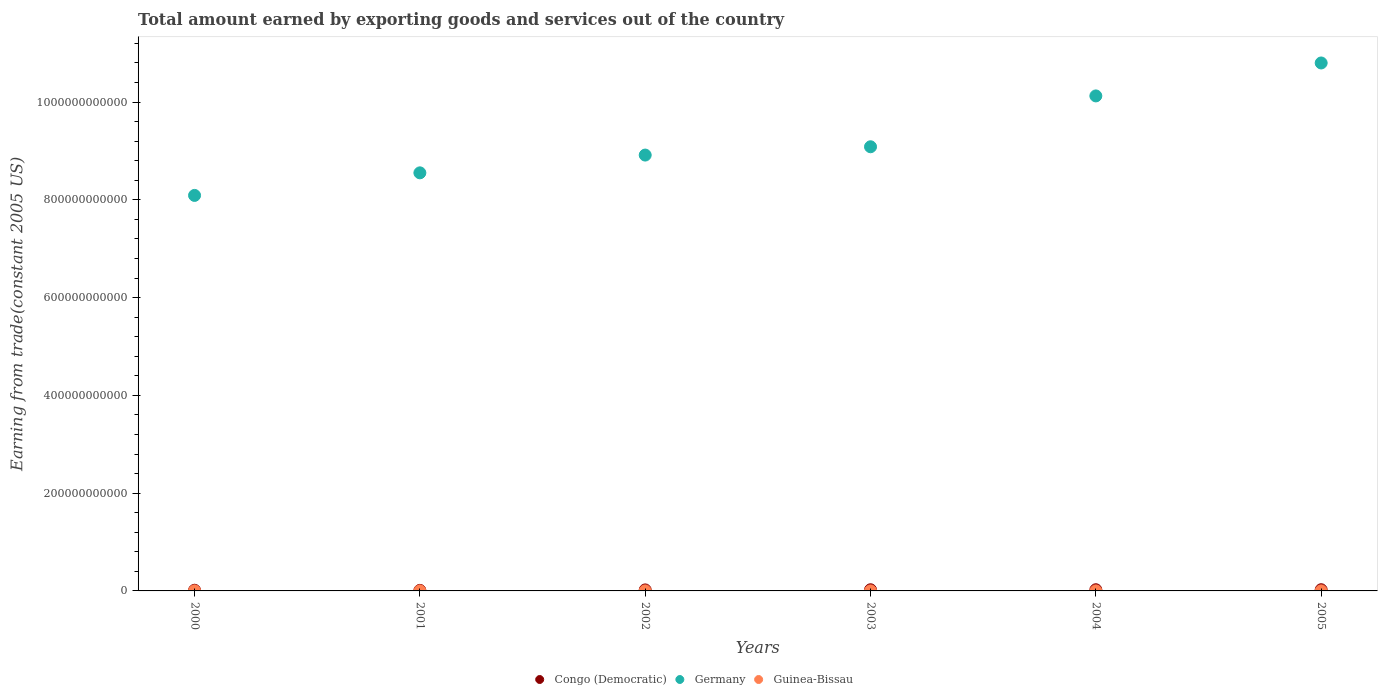What is the total amount earned by exporting goods and services in Guinea-Bissau in 2002?
Offer a terse response. 8.60e+07. Across all years, what is the maximum total amount earned by exporting goods and services in Congo (Democratic)?
Provide a short and direct response. 2.44e+09. Across all years, what is the minimum total amount earned by exporting goods and services in Guinea-Bissau?
Your answer should be compact. 7.27e+07. In which year was the total amount earned by exporting goods and services in Germany minimum?
Your answer should be compact. 2000. What is the total total amount earned by exporting goods and services in Germany in the graph?
Your answer should be compact. 5.56e+12. What is the difference between the total amount earned by exporting goods and services in Germany in 2003 and that in 2004?
Keep it short and to the point. -1.04e+11. What is the difference between the total amount earned by exporting goods and services in Congo (Democratic) in 2002 and the total amount earned by exporting goods and services in Germany in 2005?
Keep it short and to the point. -1.08e+12. What is the average total amount earned by exporting goods and services in Germany per year?
Keep it short and to the point. 9.26e+11. In the year 2002, what is the difference between the total amount earned by exporting goods and services in Congo (Democratic) and total amount earned by exporting goods and services in Guinea-Bissau?
Provide a succinct answer. 1.97e+09. In how many years, is the total amount earned by exporting goods and services in Congo (Democratic) greater than 560000000000 US$?
Provide a short and direct response. 0. What is the ratio of the total amount earned by exporting goods and services in Guinea-Bissau in 2001 to that in 2005?
Provide a short and direct response. 0.91. What is the difference between the highest and the second highest total amount earned by exporting goods and services in Germany?
Provide a short and direct response. 6.74e+1. What is the difference between the highest and the lowest total amount earned by exporting goods and services in Congo (Democratic)?
Make the answer very short. 1.31e+09. Is the sum of the total amount earned by exporting goods and services in Guinea-Bissau in 2000 and 2004 greater than the maximum total amount earned by exporting goods and services in Germany across all years?
Your answer should be very brief. No. Does the total amount earned by exporting goods and services in Guinea-Bissau monotonically increase over the years?
Your answer should be very brief. No. Is the total amount earned by exporting goods and services in Guinea-Bissau strictly less than the total amount earned by exporting goods and services in Congo (Democratic) over the years?
Your answer should be very brief. Yes. How many dotlines are there?
Your answer should be compact. 3. What is the difference between two consecutive major ticks on the Y-axis?
Ensure brevity in your answer.  2.00e+11. Where does the legend appear in the graph?
Provide a succinct answer. Bottom center. How many legend labels are there?
Make the answer very short. 3. What is the title of the graph?
Your response must be concise. Total amount earned by exporting goods and services out of the country. What is the label or title of the X-axis?
Provide a succinct answer. Years. What is the label or title of the Y-axis?
Offer a terse response. Earning from trade(constant 2005 US). What is the Earning from trade(constant 2005 US) of Congo (Democratic) in 2000?
Your answer should be compact. 1.40e+09. What is the Earning from trade(constant 2005 US) in Germany in 2000?
Your answer should be compact. 8.09e+11. What is the Earning from trade(constant 2005 US) in Guinea-Bissau in 2000?
Keep it short and to the point. 9.65e+07. What is the Earning from trade(constant 2005 US) of Congo (Democratic) in 2001?
Your answer should be very brief. 1.13e+09. What is the Earning from trade(constant 2005 US) of Germany in 2001?
Keep it short and to the point. 8.55e+11. What is the Earning from trade(constant 2005 US) in Guinea-Bissau in 2001?
Your answer should be very brief. 1.06e+08. What is the Earning from trade(constant 2005 US) of Congo (Democratic) in 2002?
Offer a terse response. 2.06e+09. What is the Earning from trade(constant 2005 US) of Germany in 2002?
Offer a very short reply. 8.92e+11. What is the Earning from trade(constant 2005 US) in Guinea-Bissau in 2002?
Provide a succinct answer. 8.60e+07. What is the Earning from trade(constant 2005 US) in Congo (Democratic) in 2003?
Provide a succinct answer. 2.36e+09. What is the Earning from trade(constant 2005 US) of Germany in 2003?
Provide a short and direct response. 9.09e+11. What is the Earning from trade(constant 2005 US) in Guinea-Bissau in 2003?
Provide a short and direct response. 7.27e+07. What is the Earning from trade(constant 2005 US) of Congo (Democratic) in 2004?
Provide a short and direct response. 2.43e+09. What is the Earning from trade(constant 2005 US) of Germany in 2004?
Give a very brief answer. 1.01e+12. What is the Earning from trade(constant 2005 US) in Guinea-Bissau in 2004?
Make the answer very short. 8.50e+07. What is the Earning from trade(constant 2005 US) in Congo (Democratic) in 2005?
Ensure brevity in your answer.  2.44e+09. What is the Earning from trade(constant 2005 US) in Germany in 2005?
Your answer should be very brief. 1.08e+12. What is the Earning from trade(constant 2005 US) of Guinea-Bissau in 2005?
Ensure brevity in your answer.  1.17e+08. Across all years, what is the maximum Earning from trade(constant 2005 US) in Congo (Democratic)?
Ensure brevity in your answer.  2.44e+09. Across all years, what is the maximum Earning from trade(constant 2005 US) of Germany?
Provide a short and direct response. 1.08e+12. Across all years, what is the maximum Earning from trade(constant 2005 US) in Guinea-Bissau?
Provide a short and direct response. 1.17e+08. Across all years, what is the minimum Earning from trade(constant 2005 US) of Congo (Democratic)?
Ensure brevity in your answer.  1.13e+09. Across all years, what is the minimum Earning from trade(constant 2005 US) in Germany?
Make the answer very short. 8.09e+11. Across all years, what is the minimum Earning from trade(constant 2005 US) of Guinea-Bissau?
Ensure brevity in your answer.  7.27e+07. What is the total Earning from trade(constant 2005 US) of Congo (Democratic) in the graph?
Offer a very short reply. 1.18e+1. What is the total Earning from trade(constant 2005 US) of Germany in the graph?
Keep it short and to the point. 5.56e+12. What is the total Earning from trade(constant 2005 US) of Guinea-Bissau in the graph?
Your answer should be compact. 5.63e+08. What is the difference between the Earning from trade(constant 2005 US) of Congo (Democratic) in 2000 and that in 2001?
Offer a terse response. 2.73e+08. What is the difference between the Earning from trade(constant 2005 US) of Germany in 2000 and that in 2001?
Provide a short and direct response. -4.62e+1. What is the difference between the Earning from trade(constant 2005 US) of Guinea-Bissau in 2000 and that in 2001?
Your answer should be compact. -9.87e+06. What is the difference between the Earning from trade(constant 2005 US) of Congo (Democratic) in 2000 and that in 2002?
Give a very brief answer. -6.58e+08. What is the difference between the Earning from trade(constant 2005 US) of Germany in 2000 and that in 2002?
Provide a short and direct response. -8.25e+1. What is the difference between the Earning from trade(constant 2005 US) of Guinea-Bissau in 2000 and that in 2002?
Ensure brevity in your answer.  1.06e+07. What is the difference between the Earning from trade(constant 2005 US) of Congo (Democratic) in 2000 and that in 2003?
Keep it short and to the point. -9.62e+08. What is the difference between the Earning from trade(constant 2005 US) of Germany in 2000 and that in 2003?
Provide a short and direct response. -9.95e+1. What is the difference between the Earning from trade(constant 2005 US) of Guinea-Bissau in 2000 and that in 2003?
Your answer should be compact. 2.39e+07. What is the difference between the Earning from trade(constant 2005 US) in Congo (Democratic) in 2000 and that in 2004?
Keep it short and to the point. -1.03e+09. What is the difference between the Earning from trade(constant 2005 US) in Germany in 2000 and that in 2004?
Give a very brief answer. -2.04e+11. What is the difference between the Earning from trade(constant 2005 US) of Guinea-Bissau in 2000 and that in 2004?
Give a very brief answer. 1.16e+07. What is the difference between the Earning from trade(constant 2005 US) in Congo (Democratic) in 2000 and that in 2005?
Offer a very short reply. -1.04e+09. What is the difference between the Earning from trade(constant 2005 US) of Germany in 2000 and that in 2005?
Your response must be concise. -2.71e+11. What is the difference between the Earning from trade(constant 2005 US) of Guinea-Bissau in 2000 and that in 2005?
Offer a terse response. -2.00e+07. What is the difference between the Earning from trade(constant 2005 US) of Congo (Democratic) in 2001 and that in 2002?
Your answer should be very brief. -9.31e+08. What is the difference between the Earning from trade(constant 2005 US) of Germany in 2001 and that in 2002?
Offer a very short reply. -3.64e+1. What is the difference between the Earning from trade(constant 2005 US) of Guinea-Bissau in 2001 and that in 2002?
Ensure brevity in your answer.  2.05e+07. What is the difference between the Earning from trade(constant 2005 US) of Congo (Democratic) in 2001 and that in 2003?
Offer a very short reply. -1.24e+09. What is the difference between the Earning from trade(constant 2005 US) of Germany in 2001 and that in 2003?
Ensure brevity in your answer.  -5.33e+1. What is the difference between the Earning from trade(constant 2005 US) of Guinea-Bissau in 2001 and that in 2003?
Offer a terse response. 3.38e+07. What is the difference between the Earning from trade(constant 2005 US) in Congo (Democratic) in 2001 and that in 2004?
Your response must be concise. -1.30e+09. What is the difference between the Earning from trade(constant 2005 US) of Germany in 2001 and that in 2004?
Your response must be concise. -1.57e+11. What is the difference between the Earning from trade(constant 2005 US) in Guinea-Bissau in 2001 and that in 2004?
Provide a succinct answer. 2.15e+07. What is the difference between the Earning from trade(constant 2005 US) of Congo (Democratic) in 2001 and that in 2005?
Your answer should be compact. -1.31e+09. What is the difference between the Earning from trade(constant 2005 US) in Germany in 2001 and that in 2005?
Provide a succinct answer. -2.25e+11. What is the difference between the Earning from trade(constant 2005 US) of Guinea-Bissau in 2001 and that in 2005?
Make the answer very short. -1.01e+07. What is the difference between the Earning from trade(constant 2005 US) in Congo (Democratic) in 2002 and that in 2003?
Offer a terse response. -3.04e+08. What is the difference between the Earning from trade(constant 2005 US) in Germany in 2002 and that in 2003?
Make the answer very short. -1.70e+1. What is the difference between the Earning from trade(constant 2005 US) of Guinea-Bissau in 2002 and that in 2003?
Ensure brevity in your answer.  1.33e+07. What is the difference between the Earning from trade(constant 2005 US) in Congo (Democratic) in 2002 and that in 2004?
Give a very brief answer. -3.69e+08. What is the difference between the Earning from trade(constant 2005 US) of Germany in 2002 and that in 2004?
Your answer should be compact. -1.21e+11. What is the difference between the Earning from trade(constant 2005 US) in Guinea-Bissau in 2002 and that in 2004?
Ensure brevity in your answer.  1.01e+06. What is the difference between the Earning from trade(constant 2005 US) of Congo (Democratic) in 2002 and that in 2005?
Keep it short and to the point. -3.82e+08. What is the difference between the Earning from trade(constant 2005 US) in Germany in 2002 and that in 2005?
Keep it short and to the point. -1.88e+11. What is the difference between the Earning from trade(constant 2005 US) in Guinea-Bissau in 2002 and that in 2005?
Keep it short and to the point. -3.05e+07. What is the difference between the Earning from trade(constant 2005 US) in Congo (Democratic) in 2003 and that in 2004?
Offer a terse response. -6.48e+07. What is the difference between the Earning from trade(constant 2005 US) of Germany in 2003 and that in 2004?
Your answer should be compact. -1.04e+11. What is the difference between the Earning from trade(constant 2005 US) of Guinea-Bissau in 2003 and that in 2004?
Provide a short and direct response. -1.23e+07. What is the difference between the Earning from trade(constant 2005 US) of Congo (Democratic) in 2003 and that in 2005?
Ensure brevity in your answer.  -7.79e+07. What is the difference between the Earning from trade(constant 2005 US) in Germany in 2003 and that in 2005?
Offer a very short reply. -1.71e+11. What is the difference between the Earning from trade(constant 2005 US) of Guinea-Bissau in 2003 and that in 2005?
Offer a very short reply. -4.38e+07. What is the difference between the Earning from trade(constant 2005 US) of Congo (Democratic) in 2004 and that in 2005?
Offer a very short reply. -1.31e+07. What is the difference between the Earning from trade(constant 2005 US) of Germany in 2004 and that in 2005?
Your answer should be very brief. -6.74e+1. What is the difference between the Earning from trade(constant 2005 US) in Guinea-Bissau in 2004 and that in 2005?
Your answer should be compact. -3.15e+07. What is the difference between the Earning from trade(constant 2005 US) of Congo (Democratic) in 2000 and the Earning from trade(constant 2005 US) of Germany in 2001?
Make the answer very short. -8.54e+11. What is the difference between the Earning from trade(constant 2005 US) in Congo (Democratic) in 2000 and the Earning from trade(constant 2005 US) in Guinea-Bissau in 2001?
Provide a succinct answer. 1.30e+09. What is the difference between the Earning from trade(constant 2005 US) in Germany in 2000 and the Earning from trade(constant 2005 US) in Guinea-Bissau in 2001?
Your answer should be compact. 8.09e+11. What is the difference between the Earning from trade(constant 2005 US) of Congo (Democratic) in 2000 and the Earning from trade(constant 2005 US) of Germany in 2002?
Your answer should be very brief. -8.90e+11. What is the difference between the Earning from trade(constant 2005 US) in Congo (Democratic) in 2000 and the Earning from trade(constant 2005 US) in Guinea-Bissau in 2002?
Ensure brevity in your answer.  1.32e+09. What is the difference between the Earning from trade(constant 2005 US) in Germany in 2000 and the Earning from trade(constant 2005 US) in Guinea-Bissau in 2002?
Your answer should be compact. 8.09e+11. What is the difference between the Earning from trade(constant 2005 US) in Congo (Democratic) in 2000 and the Earning from trade(constant 2005 US) in Germany in 2003?
Provide a short and direct response. -9.07e+11. What is the difference between the Earning from trade(constant 2005 US) in Congo (Democratic) in 2000 and the Earning from trade(constant 2005 US) in Guinea-Bissau in 2003?
Your response must be concise. 1.33e+09. What is the difference between the Earning from trade(constant 2005 US) in Germany in 2000 and the Earning from trade(constant 2005 US) in Guinea-Bissau in 2003?
Your response must be concise. 8.09e+11. What is the difference between the Earning from trade(constant 2005 US) of Congo (Democratic) in 2000 and the Earning from trade(constant 2005 US) of Germany in 2004?
Your answer should be very brief. -1.01e+12. What is the difference between the Earning from trade(constant 2005 US) of Congo (Democratic) in 2000 and the Earning from trade(constant 2005 US) of Guinea-Bissau in 2004?
Make the answer very short. 1.32e+09. What is the difference between the Earning from trade(constant 2005 US) in Germany in 2000 and the Earning from trade(constant 2005 US) in Guinea-Bissau in 2004?
Offer a terse response. 8.09e+11. What is the difference between the Earning from trade(constant 2005 US) of Congo (Democratic) in 2000 and the Earning from trade(constant 2005 US) of Germany in 2005?
Make the answer very short. -1.08e+12. What is the difference between the Earning from trade(constant 2005 US) of Congo (Democratic) in 2000 and the Earning from trade(constant 2005 US) of Guinea-Bissau in 2005?
Give a very brief answer. 1.29e+09. What is the difference between the Earning from trade(constant 2005 US) of Germany in 2000 and the Earning from trade(constant 2005 US) of Guinea-Bissau in 2005?
Give a very brief answer. 8.09e+11. What is the difference between the Earning from trade(constant 2005 US) of Congo (Democratic) in 2001 and the Earning from trade(constant 2005 US) of Germany in 2002?
Offer a terse response. -8.90e+11. What is the difference between the Earning from trade(constant 2005 US) in Congo (Democratic) in 2001 and the Earning from trade(constant 2005 US) in Guinea-Bissau in 2002?
Your response must be concise. 1.04e+09. What is the difference between the Earning from trade(constant 2005 US) of Germany in 2001 and the Earning from trade(constant 2005 US) of Guinea-Bissau in 2002?
Ensure brevity in your answer.  8.55e+11. What is the difference between the Earning from trade(constant 2005 US) of Congo (Democratic) in 2001 and the Earning from trade(constant 2005 US) of Germany in 2003?
Make the answer very short. -9.07e+11. What is the difference between the Earning from trade(constant 2005 US) in Congo (Democratic) in 2001 and the Earning from trade(constant 2005 US) in Guinea-Bissau in 2003?
Ensure brevity in your answer.  1.06e+09. What is the difference between the Earning from trade(constant 2005 US) in Germany in 2001 and the Earning from trade(constant 2005 US) in Guinea-Bissau in 2003?
Make the answer very short. 8.55e+11. What is the difference between the Earning from trade(constant 2005 US) in Congo (Democratic) in 2001 and the Earning from trade(constant 2005 US) in Germany in 2004?
Your answer should be compact. -1.01e+12. What is the difference between the Earning from trade(constant 2005 US) of Congo (Democratic) in 2001 and the Earning from trade(constant 2005 US) of Guinea-Bissau in 2004?
Your answer should be very brief. 1.04e+09. What is the difference between the Earning from trade(constant 2005 US) in Germany in 2001 and the Earning from trade(constant 2005 US) in Guinea-Bissau in 2004?
Your response must be concise. 8.55e+11. What is the difference between the Earning from trade(constant 2005 US) of Congo (Democratic) in 2001 and the Earning from trade(constant 2005 US) of Germany in 2005?
Offer a very short reply. -1.08e+12. What is the difference between the Earning from trade(constant 2005 US) of Congo (Democratic) in 2001 and the Earning from trade(constant 2005 US) of Guinea-Bissau in 2005?
Offer a terse response. 1.01e+09. What is the difference between the Earning from trade(constant 2005 US) in Germany in 2001 and the Earning from trade(constant 2005 US) in Guinea-Bissau in 2005?
Your answer should be very brief. 8.55e+11. What is the difference between the Earning from trade(constant 2005 US) in Congo (Democratic) in 2002 and the Earning from trade(constant 2005 US) in Germany in 2003?
Make the answer very short. -9.06e+11. What is the difference between the Earning from trade(constant 2005 US) in Congo (Democratic) in 2002 and the Earning from trade(constant 2005 US) in Guinea-Bissau in 2003?
Provide a succinct answer. 1.99e+09. What is the difference between the Earning from trade(constant 2005 US) in Germany in 2002 and the Earning from trade(constant 2005 US) in Guinea-Bissau in 2003?
Your response must be concise. 8.91e+11. What is the difference between the Earning from trade(constant 2005 US) of Congo (Democratic) in 2002 and the Earning from trade(constant 2005 US) of Germany in 2004?
Make the answer very short. -1.01e+12. What is the difference between the Earning from trade(constant 2005 US) of Congo (Democratic) in 2002 and the Earning from trade(constant 2005 US) of Guinea-Bissau in 2004?
Your answer should be compact. 1.98e+09. What is the difference between the Earning from trade(constant 2005 US) in Germany in 2002 and the Earning from trade(constant 2005 US) in Guinea-Bissau in 2004?
Ensure brevity in your answer.  8.91e+11. What is the difference between the Earning from trade(constant 2005 US) in Congo (Democratic) in 2002 and the Earning from trade(constant 2005 US) in Germany in 2005?
Your answer should be compact. -1.08e+12. What is the difference between the Earning from trade(constant 2005 US) of Congo (Democratic) in 2002 and the Earning from trade(constant 2005 US) of Guinea-Bissau in 2005?
Offer a very short reply. 1.94e+09. What is the difference between the Earning from trade(constant 2005 US) in Germany in 2002 and the Earning from trade(constant 2005 US) in Guinea-Bissau in 2005?
Keep it short and to the point. 8.91e+11. What is the difference between the Earning from trade(constant 2005 US) in Congo (Democratic) in 2003 and the Earning from trade(constant 2005 US) in Germany in 2004?
Your answer should be very brief. -1.01e+12. What is the difference between the Earning from trade(constant 2005 US) in Congo (Democratic) in 2003 and the Earning from trade(constant 2005 US) in Guinea-Bissau in 2004?
Provide a succinct answer. 2.28e+09. What is the difference between the Earning from trade(constant 2005 US) in Germany in 2003 and the Earning from trade(constant 2005 US) in Guinea-Bissau in 2004?
Offer a terse response. 9.08e+11. What is the difference between the Earning from trade(constant 2005 US) in Congo (Democratic) in 2003 and the Earning from trade(constant 2005 US) in Germany in 2005?
Keep it short and to the point. -1.08e+12. What is the difference between the Earning from trade(constant 2005 US) of Congo (Democratic) in 2003 and the Earning from trade(constant 2005 US) of Guinea-Bissau in 2005?
Ensure brevity in your answer.  2.25e+09. What is the difference between the Earning from trade(constant 2005 US) in Germany in 2003 and the Earning from trade(constant 2005 US) in Guinea-Bissau in 2005?
Your answer should be very brief. 9.08e+11. What is the difference between the Earning from trade(constant 2005 US) of Congo (Democratic) in 2004 and the Earning from trade(constant 2005 US) of Germany in 2005?
Offer a very short reply. -1.08e+12. What is the difference between the Earning from trade(constant 2005 US) of Congo (Democratic) in 2004 and the Earning from trade(constant 2005 US) of Guinea-Bissau in 2005?
Your response must be concise. 2.31e+09. What is the difference between the Earning from trade(constant 2005 US) of Germany in 2004 and the Earning from trade(constant 2005 US) of Guinea-Bissau in 2005?
Provide a succinct answer. 1.01e+12. What is the average Earning from trade(constant 2005 US) of Congo (Democratic) per year?
Provide a succinct answer. 1.97e+09. What is the average Earning from trade(constant 2005 US) in Germany per year?
Your response must be concise. 9.26e+11. What is the average Earning from trade(constant 2005 US) in Guinea-Bissau per year?
Ensure brevity in your answer.  9.38e+07. In the year 2000, what is the difference between the Earning from trade(constant 2005 US) in Congo (Democratic) and Earning from trade(constant 2005 US) in Germany?
Offer a terse response. -8.08e+11. In the year 2000, what is the difference between the Earning from trade(constant 2005 US) in Congo (Democratic) and Earning from trade(constant 2005 US) in Guinea-Bissau?
Offer a terse response. 1.31e+09. In the year 2000, what is the difference between the Earning from trade(constant 2005 US) in Germany and Earning from trade(constant 2005 US) in Guinea-Bissau?
Offer a terse response. 8.09e+11. In the year 2001, what is the difference between the Earning from trade(constant 2005 US) in Congo (Democratic) and Earning from trade(constant 2005 US) in Germany?
Your answer should be compact. -8.54e+11. In the year 2001, what is the difference between the Earning from trade(constant 2005 US) of Congo (Democratic) and Earning from trade(constant 2005 US) of Guinea-Bissau?
Your answer should be very brief. 1.02e+09. In the year 2001, what is the difference between the Earning from trade(constant 2005 US) of Germany and Earning from trade(constant 2005 US) of Guinea-Bissau?
Your answer should be very brief. 8.55e+11. In the year 2002, what is the difference between the Earning from trade(constant 2005 US) in Congo (Democratic) and Earning from trade(constant 2005 US) in Germany?
Ensure brevity in your answer.  -8.89e+11. In the year 2002, what is the difference between the Earning from trade(constant 2005 US) of Congo (Democratic) and Earning from trade(constant 2005 US) of Guinea-Bissau?
Make the answer very short. 1.97e+09. In the year 2002, what is the difference between the Earning from trade(constant 2005 US) in Germany and Earning from trade(constant 2005 US) in Guinea-Bissau?
Provide a short and direct response. 8.91e+11. In the year 2003, what is the difference between the Earning from trade(constant 2005 US) in Congo (Democratic) and Earning from trade(constant 2005 US) in Germany?
Offer a terse response. -9.06e+11. In the year 2003, what is the difference between the Earning from trade(constant 2005 US) in Congo (Democratic) and Earning from trade(constant 2005 US) in Guinea-Bissau?
Offer a very short reply. 2.29e+09. In the year 2003, what is the difference between the Earning from trade(constant 2005 US) in Germany and Earning from trade(constant 2005 US) in Guinea-Bissau?
Ensure brevity in your answer.  9.08e+11. In the year 2004, what is the difference between the Earning from trade(constant 2005 US) of Congo (Democratic) and Earning from trade(constant 2005 US) of Germany?
Ensure brevity in your answer.  -1.01e+12. In the year 2004, what is the difference between the Earning from trade(constant 2005 US) in Congo (Democratic) and Earning from trade(constant 2005 US) in Guinea-Bissau?
Keep it short and to the point. 2.34e+09. In the year 2004, what is the difference between the Earning from trade(constant 2005 US) in Germany and Earning from trade(constant 2005 US) in Guinea-Bissau?
Offer a very short reply. 1.01e+12. In the year 2005, what is the difference between the Earning from trade(constant 2005 US) of Congo (Democratic) and Earning from trade(constant 2005 US) of Germany?
Make the answer very short. -1.08e+12. In the year 2005, what is the difference between the Earning from trade(constant 2005 US) of Congo (Democratic) and Earning from trade(constant 2005 US) of Guinea-Bissau?
Provide a short and direct response. 2.33e+09. In the year 2005, what is the difference between the Earning from trade(constant 2005 US) of Germany and Earning from trade(constant 2005 US) of Guinea-Bissau?
Give a very brief answer. 1.08e+12. What is the ratio of the Earning from trade(constant 2005 US) of Congo (Democratic) in 2000 to that in 2001?
Offer a terse response. 1.24. What is the ratio of the Earning from trade(constant 2005 US) of Germany in 2000 to that in 2001?
Your answer should be very brief. 0.95. What is the ratio of the Earning from trade(constant 2005 US) in Guinea-Bissau in 2000 to that in 2001?
Offer a terse response. 0.91. What is the ratio of the Earning from trade(constant 2005 US) in Congo (Democratic) in 2000 to that in 2002?
Your answer should be compact. 0.68. What is the ratio of the Earning from trade(constant 2005 US) of Germany in 2000 to that in 2002?
Provide a short and direct response. 0.91. What is the ratio of the Earning from trade(constant 2005 US) in Guinea-Bissau in 2000 to that in 2002?
Provide a short and direct response. 1.12. What is the ratio of the Earning from trade(constant 2005 US) of Congo (Democratic) in 2000 to that in 2003?
Ensure brevity in your answer.  0.59. What is the ratio of the Earning from trade(constant 2005 US) in Germany in 2000 to that in 2003?
Provide a short and direct response. 0.89. What is the ratio of the Earning from trade(constant 2005 US) in Guinea-Bissau in 2000 to that in 2003?
Offer a terse response. 1.33. What is the ratio of the Earning from trade(constant 2005 US) in Congo (Democratic) in 2000 to that in 2004?
Your answer should be compact. 0.58. What is the ratio of the Earning from trade(constant 2005 US) of Germany in 2000 to that in 2004?
Make the answer very short. 0.8. What is the ratio of the Earning from trade(constant 2005 US) of Guinea-Bissau in 2000 to that in 2004?
Ensure brevity in your answer.  1.14. What is the ratio of the Earning from trade(constant 2005 US) in Congo (Democratic) in 2000 to that in 2005?
Ensure brevity in your answer.  0.57. What is the ratio of the Earning from trade(constant 2005 US) of Germany in 2000 to that in 2005?
Your answer should be compact. 0.75. What is the ratio of the Earning from trade(constant 2005 US) in Guinea-Bissau in 2000 to that in 2005?
Your answer should be very brief. 0.83. What is the ratio of the Earning from trade(constant 2005 US) of Congo (Democratic) in 2001 to that in 2002?
Keep it short and to the point. 0.55. What is the ratio of the Earning from trade(constant 2005 US) in Germany in 2001 to that in 2002?
Give a very brief answer. 0.96. What is the ratio of the Earning from trade(constant 2005 US) of Guinea-Bissau in 2001 to that in 2002?
Your answer should be compact. 1.24. What is the ratio of the Earning from trade(constant 2005 US) of Congo (Democratic) in 2001 to that in 2003?
Your response must be concise. 0.48. What is the ratio of the Earning from trade(constant 2005 US) of Germany in 2001 to that in 2003?
Offer a very short reply. 0.94. What is the ratio of the Earning from trade(constant 2005 US) in Guinea-Bissau in 2001 to that in 2003?
Your answer should be very brief. 1.46. What is the ratio of the Earning from trade(constant 2005 US) of Congo (Democratic) in 2001 to that in 2004?
Offer a very short reply. 0.46. What is the ratio of the Earning from trade(constant 2005 US) of Germany in 2001 to that in 2004?
Keep it short and to the point. 0.84. What is the ratio of the Earning from trade(constant 2005 US) in Guinea-Bissau in 2001 to that in 2004?
Give a very brief answer. 1.25. What is the ratio of the Earning from trade(constant 2005 US) of Congo (Democratic) in 2001 to that in 2005?
Your response must be concise. 0.46. What is the ratio of the Earning from trade(constant 2005 US) of Germany in 2001 to that in 2005?
Provide a short and direct response. 0.79. What is the ratio of the Earning from trade(constant 2005 US) in Guinea-Bissau in 2001 to that in 2005?
Provide a succinct answer. 0.91. What is the ratio of the Earning from trade(constant 2005 US) in Congo (Democratic) in 2002 to that in 2003?
Offer a terse response. 0.87. What is the ratio of the Earning from trade(constant 2005 US) in Germany in 2002 to that in 2003?
Your answer should be very brief. 0.98. What is the ratio of the Earning from trade(constant 2005 US) in Guinea-Bissau in 2002 to that in 2003?
Provide a succinct answer. 1.18. What is the ratio of the Earning from trade(constant 2005 US) of Congo (Democratic) in 2002 to that in 2004?
Give a very brief answer. 0.85. What is the ratio of the Earning from trade(constant 2005 US) of Germany in 2002 to that in 2004?
Ensure brevity in your answer.  0.88. What is the ratio of the Earning from trade(constant 2005 US) of Guinea-Bissau in 2002 to that in 2004?
Your answer should be very brief. 1.01. What is the ratio of the Earning from trade(constant 2005 US) of Congo (Democratic) in 2002 to that in 2005?
Give a very brief answer. 0.84. What is the ratio of the Earning from trade(constant 2005 US) in Germany in 2002 to that in 2005?
Your answer should be compact. 0.83. What is the ratio of the Earning from trade(constant 2005 US) of Guinea-Bissau in 2002 to that in 2005?
Keep it short and to the point. 0.74. What is the ratio of the Earning from trade(constant 2005 US) in Congo (Democratic) in 2003 to that in 2004?
Your answer should be very brief. 0.97. What is the ratio of the Earning from trade(constant 2005 US) in Germany in 2003 to that in 2004?
Your response must be concise. 0.9. What is the ratio of the Earning from trade(constant 2005 US) in Guinea-Bissau in 2003 to that in 2004?
Offer a terse response. 0.86. What is the ratio of the Earning from trade(constant 2005 US) of Congo (Democratic) in 2003 to that in 2005?
Ensure brevity in your answer.  0.97. What is the ratio of the Earning from trade(constant 2005 US) in Germany in 2003 to that in 2005?
Your answer should be compact. 0.84. What is the ratio of the Earning from trade(constant 2005 US) in Guinea-Bissau in 2003 to that in 2005?
Your response must be concise. 0.62. What is the ratio of the Earning from trade(constant 2005 US) in Congo (Democratic) in 2004 to that in 2005?
Ensure brevity in your answer.  0.99. What is the ratio of the Earning from trade(constant 2005 US) in Germany in 2004 to that in 2005?
Provide a short and direct response. 0.94. What is the ratio of the Earning from trade(constant 2005 US) of Guinea-Bissau in 2004 to that in 2005?
Your response must be concise. 0.73. What is the difference between the highest and the second highest Earning from trade(constant 2005 US) in Congo (Democratic)?
Your answer should be very brief. 1.31e+07. What is the difference between the highest and the second highest Earning from trade(constant 2005 US) in Germany?
Offer a terse response. 6.74e+1. What is the difference between the highest and the second highest Earning from trade(constant 2005 US) in Guinea-Bissau?
Your answer should be compact. 1.01e+07. What is the difference between the highest and the lowest Earning from trade(constant 2005 US) in Congo (Democratic)?
Offer a very short reply. 1.31e+09. What is the difference between the highest and the lowest Earning from trade(constant 2005 US) in Germany?
Offer a very short reply. 2.71e+11. What is the difference between the highest and the lowest Earning from trade(constant 2005 US) of Guinea-Bissau?
Keep it short and to the point. 4.38e+07. 